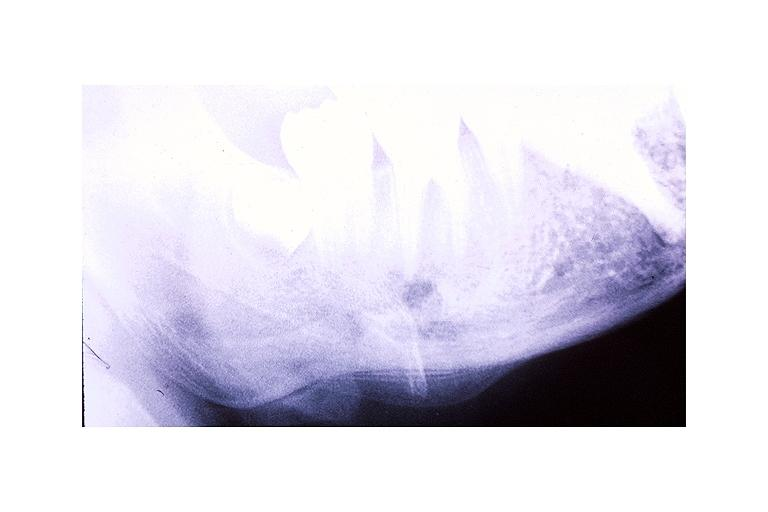s penis present?
Answer the question using a single word or phrase. No 